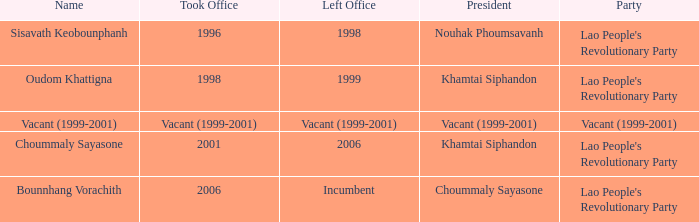What is the political party when the assumption of office occurred in 1998? Lao People's Revolutionary Party. 